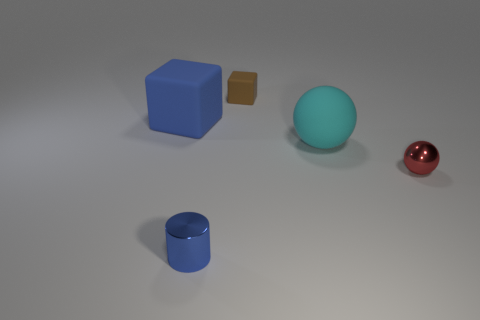There is a cyan matte object; is its size the same as the rubber thing that is on the left side of the small rubber block?
Offer a very short reply. Yes. Are there any metallic objects that are to the right of the small red metal ball to the right of the cube that is left of the small brown matte block?
Offer a very short reply. No. There is a small object behind the blue rubber block; what material is it?
Keep it short and to the point. Rubber. Do the red metal ball and the metal cylinder have the same size?
Make the answer very short. Yes. There is a thing that is in front of the cyan thing and on the right side of the tiny rubber cube; what color is it?
Your answer should be compact. Red. There is a blue thing that is made of the same material as the red object; what is its shape?
Keep it short and to the point. Cylinder. What number of objects are behind the small red sphere and to the right of the cylinder?
Provide a succinct answer. 2. Are there any small brown blocks left of the tiny blue cylinder?
Keep it short and to the point. No. Is the shape of the small object behind the big blue thing the same as the tiny metal object behind the small blue cylinder?
Provide a succinct answer. No. How many objects are big red shiny balls or things that are right of the blue rubber cube?
Give a very brief answer. 4. 